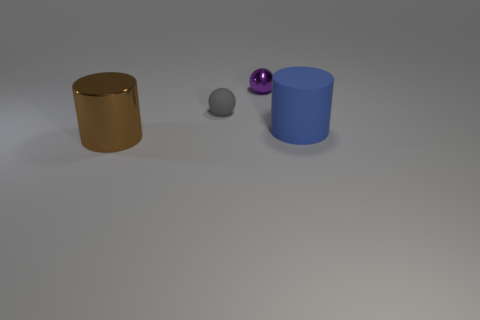Does the gray sphere have the same size as the blue cylinder?
Your answer should be compact. No. What number of objects are large cylinders or gray matte things?
Your answer should be compact. 3. What size is the thing that is both behind the rubber cylinder and on the left side of the tiny metallic ball?
Offer a very short reply. Small. Is the number of small purple balls on the left side of the gray rubber thing less than the number of purple shiny balls?
Your answer should be compact. Yes. What is the shape of the large object that is made of the same material as the tiny purple thing?
Offer a terse response. Cylinder. There is a shiny thing behind the gray matte object; does it have the same shape as the object to the right of the purple object?
Provide a short and direct response. No. Is the number of purple objects in front of the tiny gray thing less than the number of small shiny objects that are in front of the blue thing?
Your answer should be very brief. No. How many gray objects have the same size as the blue rubber cylinder?
Your answer should be compact. 0. Is the big thing on the left side of the blue cylinder made of the same material as the gray ball?
Keep it short and to the point. No. Are there any gray objects?
Give a very brief answer. Yes. 